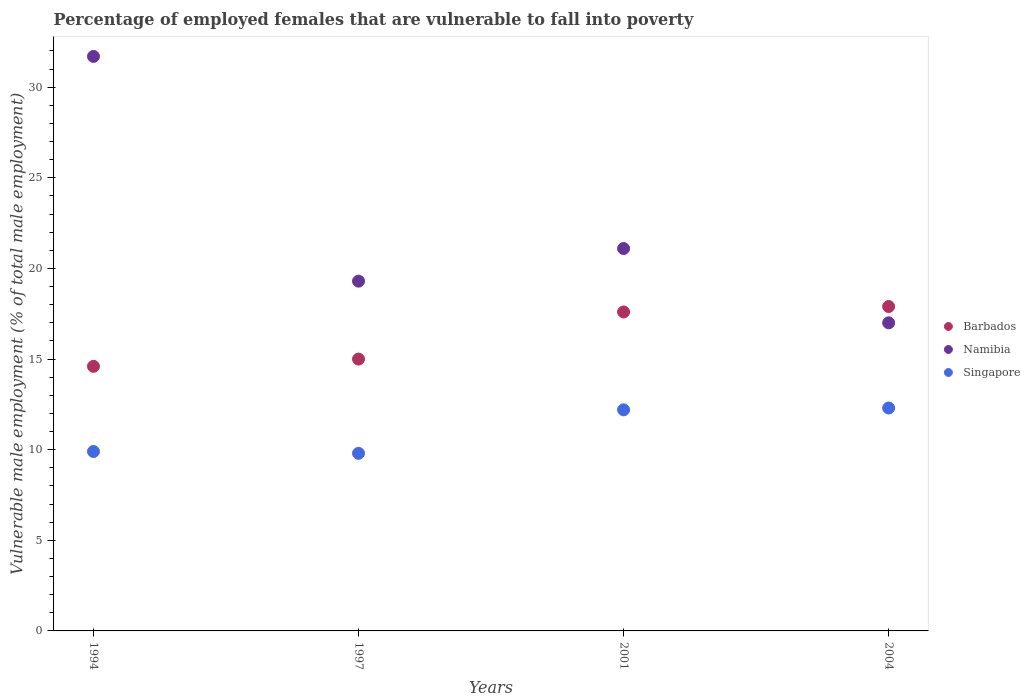Is the number of dotlines equal to the number of legend labels?
Your answer should be very brief. Yes. What is the percentage of employed females who are vulnerable to fall into poverty in Barbados in 1994?
Your response must be concise. 14.6. Across all years, what is the maximum percentage of employed females who are vulnerable to fall into poverty in Namibia?
Provide a succinct answer. 31.7. Across all years, what is the minimum percentage of employed females who are vulnerable to fall into poverty in Barbados?
Your response must be concise. 14.6. What is the total percentage of employed females who are vulnerable to fall into poverty in Singapore in the graph?
Ensure brevity in your answer.  44.2. What is the difference between the percentage of employed females who are vulnerable to fall into poverty in Namibia in 1994 and that in 2001?
Your answer should be very brief. 10.6. What is the difference between the percentage of employed females who are vulnerable to fall into poverty in Namibia in 2004 and the percentage of employed females who are vulnerable to fall into poverty in Singapore in 2001?
Offer a very short reply. 4.8. What is the average percentage of employed females who are vulnerable to fall into poverty in Namibia per year?
Provide a succinct answer. 22.28. In the year 2001, what is the difference between the percentage of employed females who are vulnerable to fall into poverty in Singapore and percentage of employed females who are vulnerable to fall into poverty in Barbados?
Make the answer very short. -5.4. In how many years, is the percentage of employed females who are vulnerable to fall into poverty in Barbados greater than 5 %?
Your answer should be compact. 4. What is the ratio of the percentage of employed females who are vulnerable to fall into poverty in Singapore in 1994 to that in 2001?
Your response must be concise. 0.81. Is the percentage of employed females who are vulnerable to fall into poverty in Barbados in 1997 less than that in 2004?
Provide a succinct answer. Yes. Is the difference between the percentage of employed females who are vulnerable to fall into poverty in Singapore in 2001 and 2004 greater than the difference between the percentage of employed females who are vulnerable to fall into poverty in Barbados in 2001 and 2004?
Ensure brevity in your answer.  Yes. What is the difference between the highest and the second highest percentage of employed females who are vulnerable to fall into poverty in Singapore?
Ensure brevity in your answer.  0.1. What is the difference between the highest and the lowest percentage of employed females who are vulnerable to fall into poverty in Barbados?
Your answer should be very brief. 3.3. In how many years, is the percentage of employed females who are vulnerable to fall into poverty in Barbados greater than the average percentage of employed females who are vulnerable to fall into poverty in Barbados taken over all years?
Keep it short and to the point. 2. Is the percentage of employed females who are vulnerable to fall into poverty in Namibia strictly greater than the percentage of employed females who are vulnerable to fall into poverty in Singapore over the years?
Offer a very short reply. Yes. Does the graph contain grids?
Give a very brief answer. No. Where does the legend appear in the graph?
Keep it short and to the point. Center right. How are the legend labels stacked?
Your response must be concise. Vertical. What is the title of the graph?
Your answer should be very brief. Percentage of employed females that are vulnerable to fall into poverty. Does "Iceland" appear as one of the legend labels in the graph?
Ensure brevity in your answer.  No. What is the label or title of the Y-axis?
Provide a short and direct response. Vulnerable male employment (% of total male employment). What is the Vulnerable male employment (% of total male employment) in Barbados in 1994?
Your response must be concise. 14.6. What is the Vulnerable male employment (% of total male employment) of Namibia in 1994?
Offer a very short reply. 31.7. What is the Vulnerable male employment (% of total male employment) of Singapore in 1994?
Your answer should be very brief. 9.9. What is the Vulnerable male employment (% of total male employment) in Barbados in 1997?
Ensure brevity in your answer.  15. What is the Vulnerable male employment (% of total male employment) of Namibia in 1997?
Ensure brevity in your answer.  19.3. What is the Vulnerable male employment (% of total male employment) of Singapore in 1997?
Provide a succinct answer. 9.8. What is the Vulnerable male employment (% of total male employment) in Barbados in 2001?
Your answer should be compact. 17.6. What is the Vulnerable male employment (% of total male employment) of Namibia in 2001?
Give a very brief answer. 21.1. What is the Vulnerable male employment (% of total male employment) in Singapore in 2001?
Provide a succinct answer. 12.2. What is the Vulnerable male employment (% of total male employment) in Barbados in 2004?
Offer a terse response. 17.9. What is the Vulnerable male employment (% of total male employment) of Namibia in 2004?
Your response must be concise. 17. What is the Vulnerable male employment (% of total male employment) of Singapore in 2004?
Ensure brevity in your answer.  12.3. Across all years, what is the maximum Vulnerable male employment (% of total male employment) of Barbados?
Keep it short and to the point. 17.9. Across all years, what is the maximum Vulnerable male employment (% of total male employment) in Namibia?
Offer a terse response. 31.7. Across all years, what is the maximum Vulnerable male employment (% of total male employment) in Singapore?
Give a very brief answer. 12.3. Across all years, what is the minimum Vulnerable male employment (% of total male employment) in Barbados?
Ensure brevity in your answer.  14.6. Across all years, what is the minimum Vulnerable male employment (% of total male employment) in Namibia?
Offer a very short reply. 17. Across all years, what is the minimum Vulnerable male employment (% of total male employment) in Singapore?
Offer a terse response. 9.8. What is the total Vulnerable male employment (% of total male employment) in Barbados in the graph?
Offer a very short reply. 65.1. What is the total Vulnerable male employment (% of total male employment) in Namibia in the graph?
Provide a short and direct response. 89.1. What is the total Vulnerable male employment (% of total male employment) of Singapore in the graph?
Provide a succinct answer. 44.2. What is the difference between the Vulnerable male employment (% of total male employment) of Singapore in 1994 and that in 2001?
Your answer should be very brief. -2.3. What is the difference between the Vulnerable male employment (% of total male employment) of Barbados in 1994 and that in 2004?
Give a very brief answer. -3.3. What is the difference between the Vulnerable male employment (% of total male employment) of Singapore in 1994 and that in 2004?
Ensure brevity in your answer.  -2.4. What is the difference between the Vulnerable male employment (% of total male employment) in Namibia in 1997 and that in 2001?
Provide a short and direct response. -1.8. What is the difference between the Vulnerable male employment (% of total male employment) of Barbados in 1997 and that in 2004?
Ensure brevity in your answer.  -2.9. What is the difference between the Vulnerable male employment (% of total male employment) in Namibia in 2001 and that in 2004?
Make the answer very short. 4.1. What is the difference between the Vulnerable male employment (% of total male employment) in Singapore in 2001 and that in 2004?
Give a very brief answer. -0.1. What is the difference between the Vulnerable male employment (% of total male employment) of Barbados in 1994 and the Vulnerable male employment (% of total male employment) of Namibia in 1997?
Keep it short and to the point. -4.7. What is the difference between the Vulnerable male employment (% of total male employment) of Barbados in 1994 and the Vulnerable male employment (% of total male employment) of Singapore in 1997?
Keep it short and to the point. 4.8. What is the difference between the Vulnerable male employment (% of total male employment) in Namibia in 1994 and the Vulnerable male employment (% of total male employment) in Singapore in 1997?
Keep it short and to the point. 21.9. What is the difference between the Vulnerable male employment (% of total male employment) of Barbados in 1994 and the Vulnerable male employment (% of total male employment) of Namibia in 2004?
Make the answer very short. -2.4. What is the difference between the Vulnerable male employment (% of total male employment) of Namibia in 1994 and the Vulnerable male employment (% of total male employment) of Singapore in 2004?
Offer a terse response. 19.4. What is the difference between the Vulnerable male employment (% of total male employment) of Barbados in 1997 and the Vulnerable male employment (% of total male employment) of Singapore in 2001?
Your response must be concise. 2.8. What is the difference between the Vulnerable male employment (% of total male employment) of Namibia in 1997 and the Vulnerable male employment (% of total male employment) of Singapore in 2001?
Provide a succinct answer. 7.1. What is the difference between the Vulnerable male employment (% of total male employment) of Barbados in 1997 and the Vulnerable male employment (% of total male employment) of Singapore in 2004?
Your answer should be compact. 2.7. What is the difference between the Vulnerable male employment (% of total male employment) in Barbados in 2001 and the Vulnerable male employment (% of total male employment) in Namibia in 2004?
Offer a terse response. 0.6. What is the difference between the Vulnerable male employment (% of total male employment) in Barbados in 2001 and the Vulnerable male employment (% of total male employment) in Singapore in 2004?
Ensure brevity in your answer.  5.3. What is the average Vulnerable male employment (% of total male employment) in Barbados per year?
Provide a succinct answer. 16.27. What is the average Vulnerable male employment (% of total male employment) of Namibia per year?
Your response must be concise. 22.27. What is the average Vulnerable male employment (% of total male employment) in Singapore per year?
Your response must be concise. 11.05. In the year 1994, what is the difference between the Vulnerable male employment (% of total male employment) in Barbados and Vulnerable male employment (% of total male employment) in Namibia?
Your response must be concise. -17.1. In the year 1994, what is the difference between the Vulnerable male employment (% of total male employment) of Barbados and Vulnerable male employment (% of total male employment) of Singapore?
Your answer should be very brief. 4.7. In the year 1994, what is the difference between the Vulnerable male employment (% of total male employment) of Namibia and Vulnerable male employment (% of total male employment) of Singapore?
Ensure brevity in your answer.  21.8. In the year 2001, what is the difference between the Vulnerable male employment (% of total male employment) in Barbados and Vulnerable male employment (% of total male employment) in Singapore?
Give a very brief answer. 5.4. In the year 2004, what is the difference between the Vulnerable male employment (% of total male employment) of Barbados and Vulnerable male employment (% of total male employment) of Namibia?
Your response must be concise. 0.9. In the year 2004, what is the difference between the Vulnerable male employment (% of total male employment) of Barbados and Vulnerable male employment (% of total male employment) of Singapore?
Your answer should be very brief. 5.6. In the year 2004, what is the difference between the Vulnerable male employment (% of total male employment) of Namibia and Vulnerable male employment (% of total male employment) of Singapore?
Your answer should be compact. 4.7. What is the ratio of the Vulnerable male employment (% of total male employment) of Barbados in 1994 to that in 1997?
Offer a very short reply. 0.97. What is the ratio of the Vulnerable male employment (% of total male employment) of Namibia in 1994 to that in 1997?
Keep it short and to the point. 1.64. What is the ratio of the Vulnerable male employment (% of total male employment) of Singapore in 1994 to that in 1997?
Your answer should be compact. 1.01. What is the ratio of the Vulnerable male employment (% of total male employment) in Barbados in 1994 to that in 2001?
Your answer should be very brief. 0.83. What is the ratio of the Vulnerable male employment (% of total male employment) in Namibia in 1994 to that in 2001?
Offer a very short reply. 1.5. What is the ratio of the Vulnerable male employment (% of total male employment) in Singapore in 1994 to that in 2001?
Make the answer very short. 0.81. What is the ratio of the Vulnerable male employment (% of total male employment) in Barbados in 1994 to that in 2004?
Give a very brief answer. 0.82. What is the ratio of the Vulnerable male employment (% of total male employment) of Namibia in 1994 to that in 2004?
Offer a terse response. 1.86. What is the ratio of the Vulnerable male employment (% of total male employment) of Singapore in 1994 to that in 2004?
Provide a succinct answer. 0.8. What is the ratio of the Vulnerable male employment (% of total male employment) in Barbados in 1997 to that in 2001?
Ensure brevity in your answer.  0.85. What is the ratio of the Vulnerable male employment (% of total male employment) in Namibia in 1997 to that in 2001?
Provide a succinct answer. 0.91. What is the ratio of the Vulnerable male employment (% of total male employment) of Singapore in 1997 to that in 2001?
Your answer should be very brief. 0.8. What is the ratio of the Vulnerable male employment (% of total male employment) of Barbados in 1997 to that in 2004?
Offer a very short reply. 0.84. What is the ratio of the Vulnerable male employment (% of total male employment) in Namibia in 1997 to that in 2004?
Give a very brief answer. 1.14. What is the ratio of the Vulnerable male employment (% of total male employment) in Singapore in 1997 to that in 2004?
Ensure brevity in your answer.  0.8. What is the ratio of the Vulnerable male employment (% of total male employment) of Barbados in 2001 to that in 2004?
Your answer should be very brief. 0.98. What is the ratio of the Vulnerable male employment (% of total male employment) in Namibia in 2001 to that in 2004?
Make the answer very short. 1.24. What is the ratio of the Vulnerable male employment (% of total male employment) of Singapore in 2001 to that in 2004?
Offer a terse response. 0.99. What is the difference between the highest and the second highest Vulnerable male employment (% of total male employment) of Singapore?
Provide a succinct answer. 0.1. What is the difference between the highest and the lowest Vulnerable male employment (% of total male employment) of Singapore?
Ensure brevity in your answer.  2.5. 